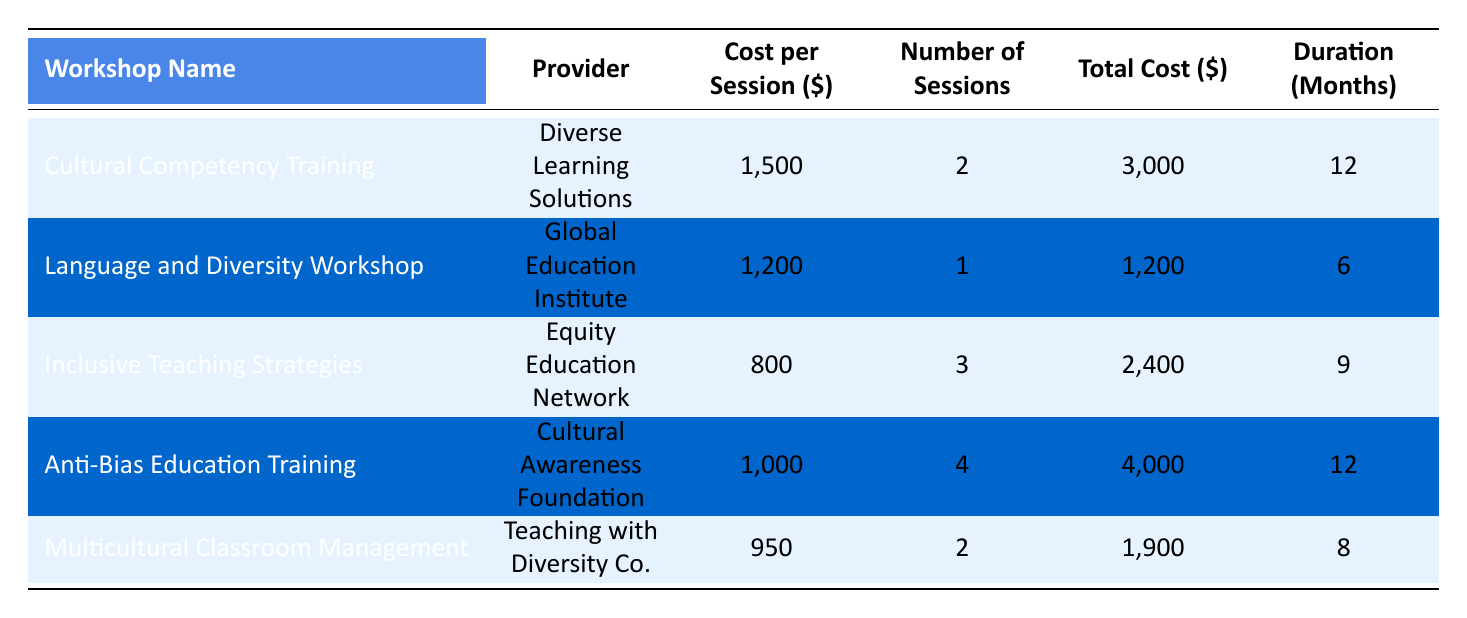What is the total cost of the Cultural Competency Training? The total cost for the Cultural Competency Training, as listed in the table, is 3,000 dollars.
Answer: 3,000 How many sessions are provided for the Inclusive Teaching Strategies workshop? The table shows that the Inclusive Teaching Strategies workshop has 3 sessions.
Answer: 3 Which workshop has the highest cost per session? Evaluating the cost per session for each workshop, the Cultural Competency Training has the highest cost at 1,500 dollars.
Answer: 1,500 What is the average total cost of all the workshops listed? The total costs are 3,000 + 1,200 + 2,400 + 4,000 + 1,900 = 12,500 dollars. There are 5 workshops, so the average total cost is 12,500/5 = 2,500 dollars.
Answer: 2,500 Is the number of sessions for the Anti-Bias Education Training greater than the number of sessions for the Multicultural Classroom Management workshop? The Anti-Bias Education Training has 4 sessions, while the Multicultural Classroom Management has 2 sessions. Since 4 is greater than 2, the statement is true.
Answer: Yes What is the total duration in months for all workshops combined? The total duration is 12 + 6 + 9 + 12 + 8 = 47 months, which combines the durations of all the workshops.
Answer: 47 Is there a workshop that has a total cost exceeding 3,000 dollars? The workshops with total costs are 3,000 (Cultural Competency Training), 1,200 (Language and Diversity Workshop), 2,400 (Inclusive Teaching Strategies), 4,000 (Anti-Bias Education Training), and 1,900 (Multicultural Classroom Management). The Anti-Bias Education Training is the only one that exceeds 3,000 dollars. Thus, the answer is yes.
Answer: Yes How much less is the total cost of the Language and Diversity Workshop compared to the total cost of the Anti-Bias Education Training? The total cost of the Language and Diversity Workshop is 1,200 dollars, while the cost of the Anti-Bias Education Training is 4,000 dollars. To find the difference, we calculate 4,000 - 1,200 = 2,800 dollars.
Answer: 2,800 Which workshop has the shortest duration? By reviewing the durations, the Language and Diversity Workshop has the shortest duration, with only 6 months.
Answer: 6 